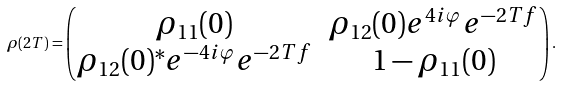Convert formula to latex. <formula><loc_0><loc_0><loc_500><loc_500>\rho ( 2 T ) = \begin{pmatrix} \rho _ { 1 1 } ( 0 ) & \rho _ { 1 2 } ( 0 ) e ^ { 4 i \varphi } e ^ { - 2 T f } \\ \rho _ { 1 2 } ( 0 ) ^ { * } e ^ { - 4 i \varphi } e ^ { - 2 T f } & 1 - \rho _ { 1 1 } ( 0 ) \end{pmatrix} .</formula> 